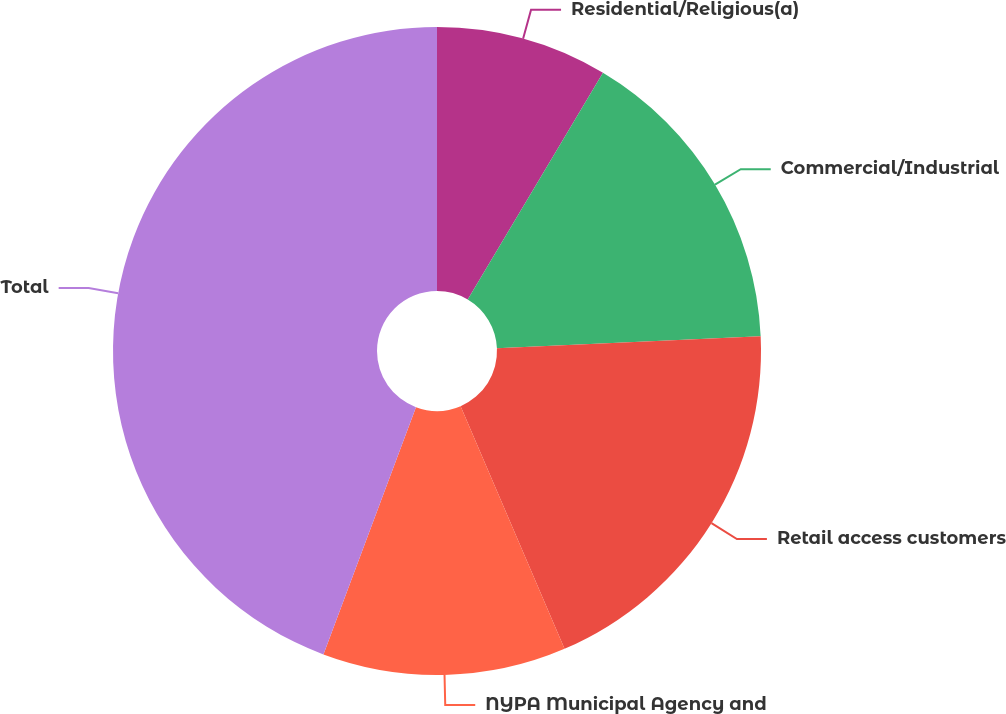Convert chart. <chart><loc_0><loc_0><loc_500><loc_500><pie_chart><fcel>Residential/Religious(a)<fcel>Commercial/Industrial<fcel>Retail access customers<fcel>NYPA Municipal Agency and<fcel>Total<nl><fcel>8.56%<fcel>15.71%<fcel>19.29%<fcel>12.14%<fcel>44.3%<nl></chart> 